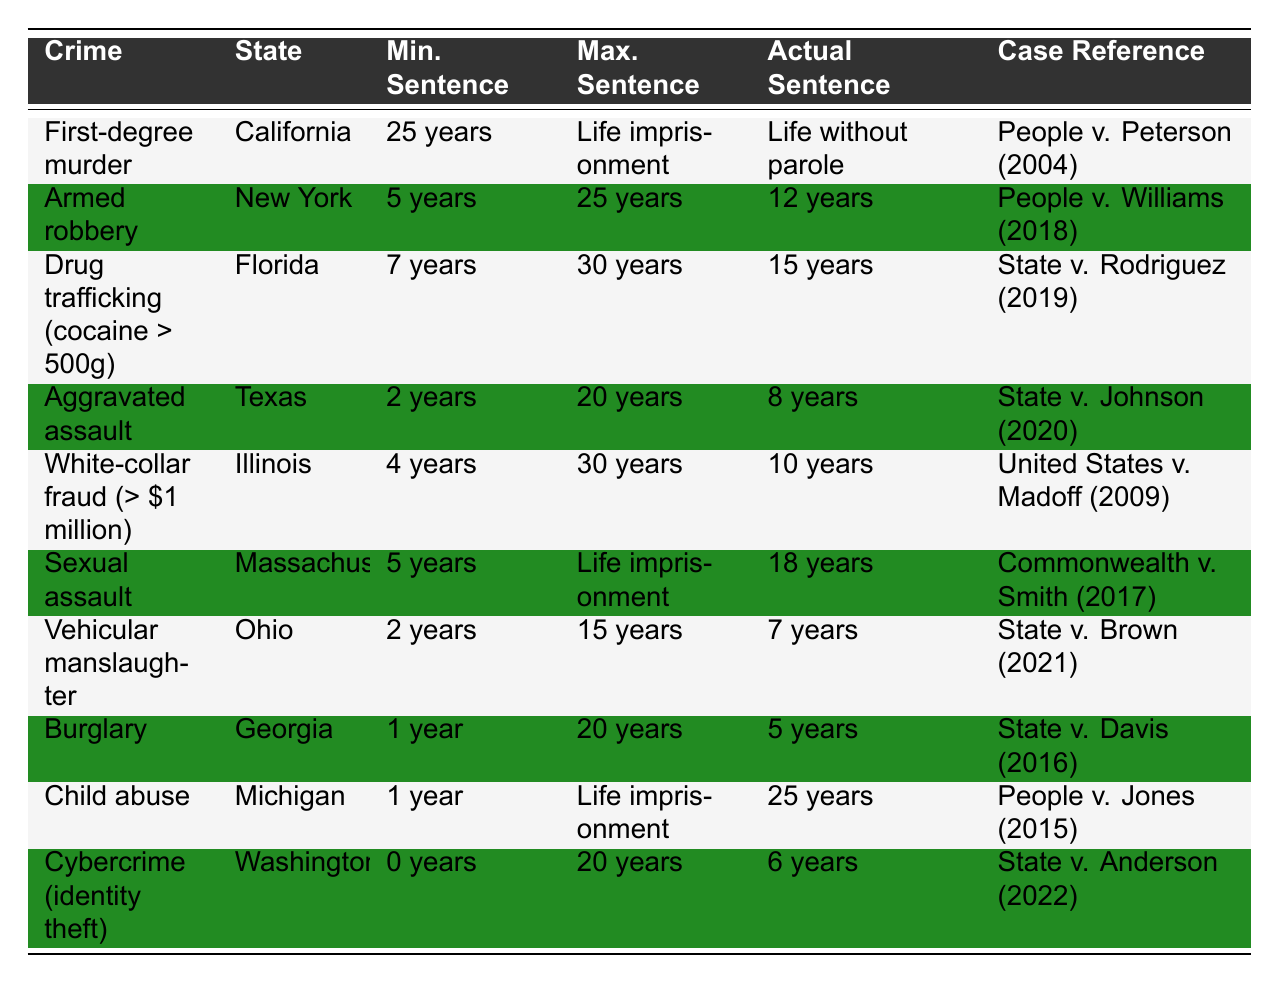What is the maximum sentence for first-degree murder in California? The table lists the maximum sentence for first-degree murder in California as "Life imprisonment."
Answer: Life imprisonment What is the actual sentence received in the case of armed robbery in New York? According to the table, the actual sentence example for armed robbery in New York is "12 years."
Answer: 12 years Which crime has the longest minimum sentence listed? By examining the table, the longest minimum sentence is for first-degree murder in California, which is "25 years."
Answer: 25 years What is the actual sentence example for drug trafficking in Florida? The table shows that the actual sentence example for drug trafficking in Florida is "15 years."
Answer: 15 years Is the maximum sentence for sexual assault in Massachusetts set to life imprisonment? Yes, the table confirms that the maximum sentence for sexual assault in Massachusetts is "Life imprisonment."
Answer: Yes What is the difference between the maximum and minimum sentences for aggravated assault in Texas? The maximum sentence is "20 years" and the minimum is "2 years," so the difference is 20 - 2 = 18 years.
Answer: 18 years How many years is the actual sentence for vehicular manslaughter in Ohio? The table indicates that the actual sentence for vehicular manslaughter in Ohio is "7 years."
Answer: 7 years Which crime had the most substantial actual sentence in the examples provided? Comparing the actual sentences, "Life without parole" for first-degree murder is the most substantial compared to other sentences listed.
Answer: Life without parole If someone committed child abuse in Michigan, what is the actual sentence they could receive? The table states that the actual sentence for child abuse in Michigan is "25 years."
Answer: 25 years What is the average maximum sentence across the crimes listed in the table? The maximum sentences are Life imprisonment (treated as a maximum of 50 years), 25 years, 30 years, 20 years, 30 years, Life imprisonment (treated as 50 years), 15 years, 20 years, Life imprisonment (50 years), and 20 years. The total is 50 + 25 + 30 + 20 + 30 + 50 + 15 + 20 + 50 + 20 = 350 years. Dividing by 10 gives an average of 35 years.
Answer: 35 years 